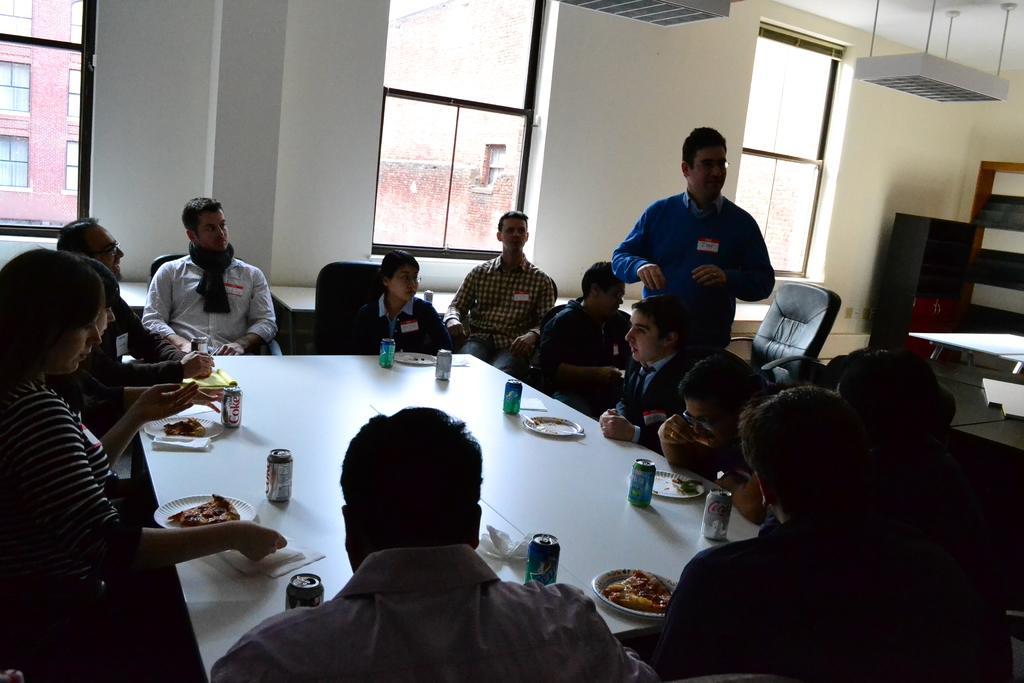In one or two sentences, can you explain what this image depicts? Her we can see a group of people are sitting on the chair, and in front here is the table and tins and plates on it, and here a person is standing, and here is the window, and here is the building. 